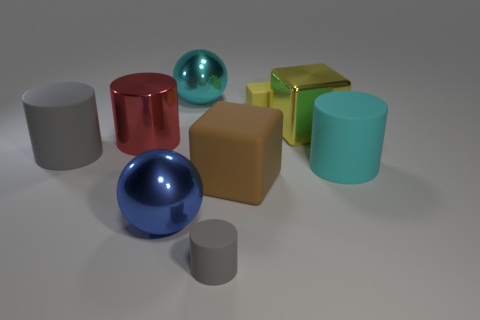Subtract all cubes. How many objects are left? 6 Add 2 blue metallic objects. How many blue metallic objects exist? 3 Subtract 0 gray blocks. How many objects are left? 9 Subtract all small cubes. Subtract all small cylinders. How many objects are left? 7 Add 3 gray objects. How many gray objects are left? 5 